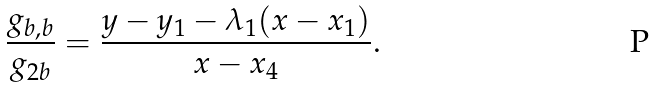<formula> <loc_0><loc_0><loc_500><loc_500>\frac { g _ { b , b } } { g _ { 2 b } } = \frac { y - y _ { 1 } - \lambda _ { 1 } ( x - x _ { 1 } ) } { x - x _ { 4 } } .</formula> 